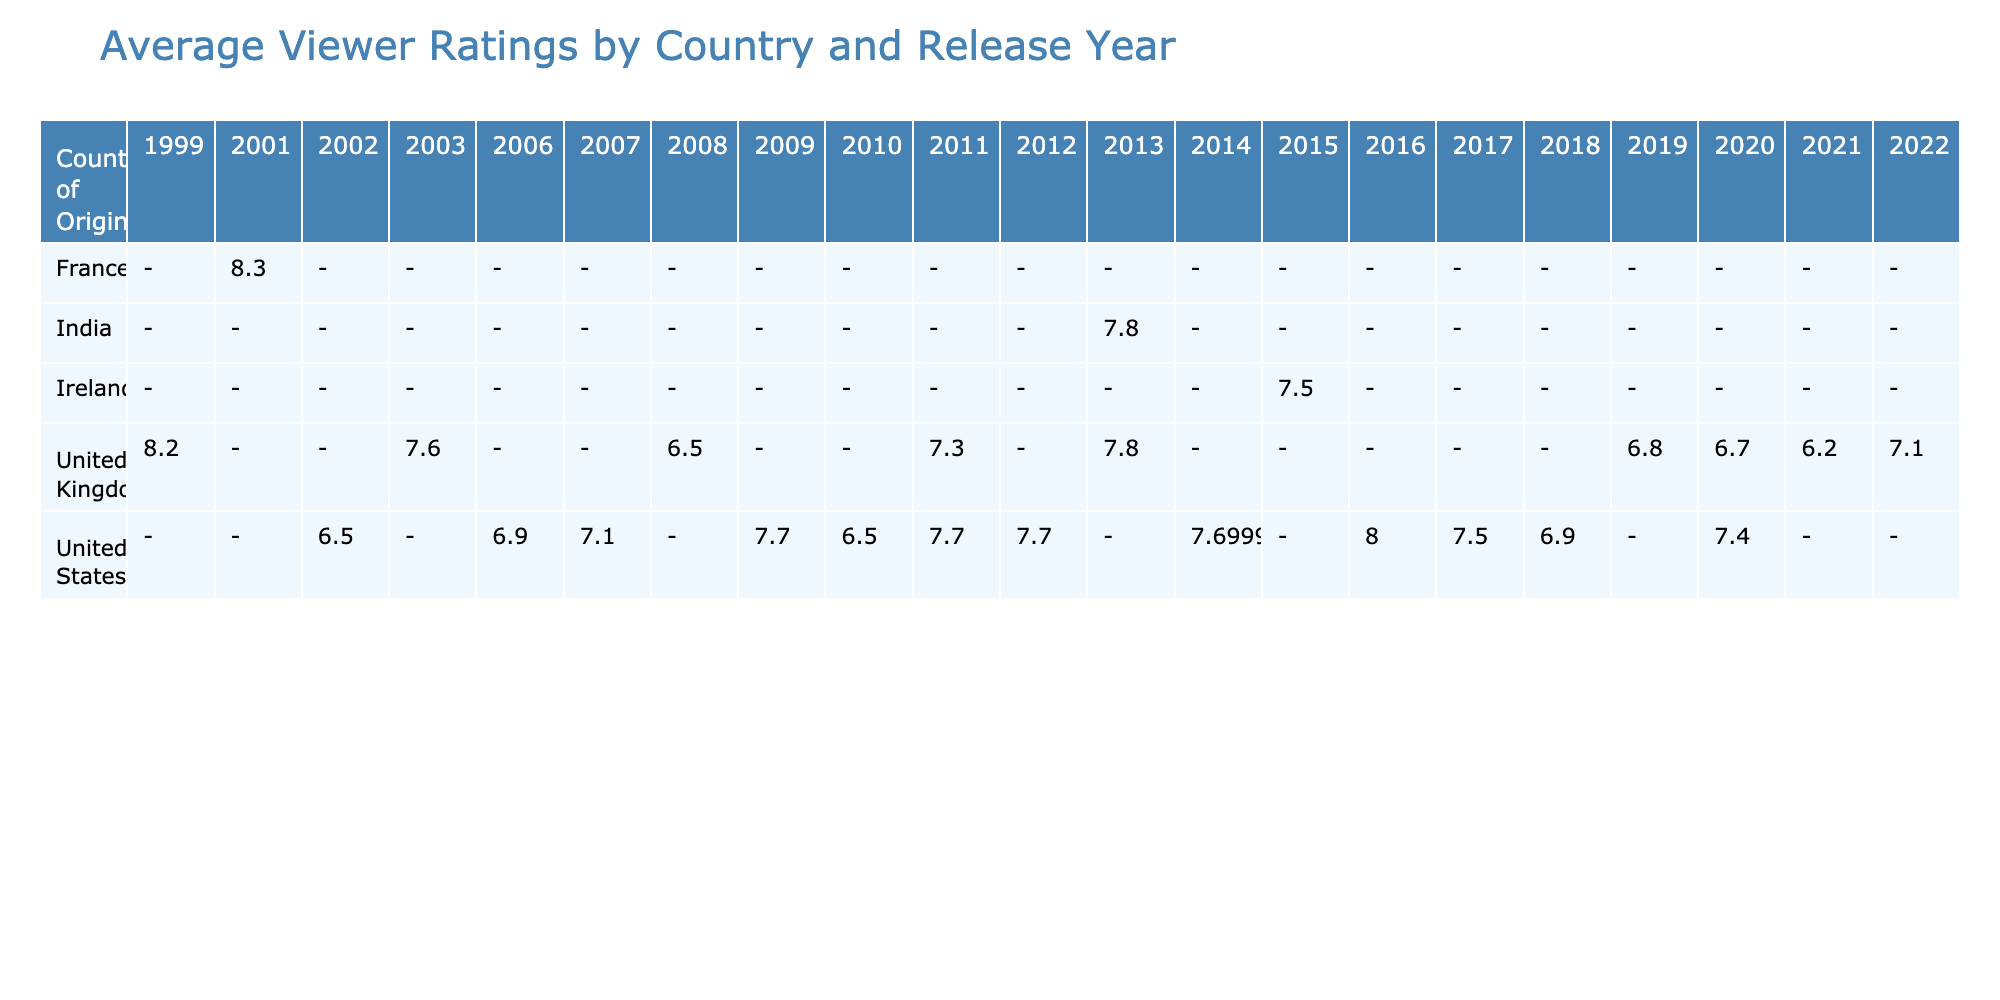What is the highest viewer rating for a romantic comedy from the United Kingdom? The highest viewer rating in the table for the United Kingdom is from "Notting Hill," which has a rating of 8.2.
Answer: 8.2 Which country had the lowest viewer rating in 2021? The table shows that the viewer rating for "Falling for Figaro" from the United Kingdom in 2021 is 6.2, which is the lowest among all ratings for that year.
Answer: 6.2 What is the average viewer rating for romantic comedies from the United States? To find the average rating, sum the viewer ratings of the romantic comedies from the United States: 6.5 + 6.9 + 7.1 + 7.7 + 6.5 + 7.7 + 7.3 + 8.1 + 7.5 + 8.0 + 6.9 + 7.4 = 86.0. There are 12 films, so the average is 86.0/12 ≈ 7.2.
Answer: 7.2 Did France produce any romantic comedies with a viewer rating above 8.0? The only French romantic comedy listed is "Amélie," which has a viewer rating of 8.3. Since this is above 8.0, the statement is true.
Answer: Yes Which country had the highest average viewer rating in 2014? In 2014, the viewer ratings for the United States were 8.1 for "The Grand Budapest Hotel" and 7.3 for "The Hundred-Foot Journey," making the average rating (8.1 + 7.3)/2 = 7.7. No other countries have data for that year, placing the United States with the highest average rating of 7.7.
Answer: United States What difference in viewer ratings is there between the highest-rated romantic comedy from the UK and the lowest-rated from the US? The highest-rated romantic comedy from the UK is "Notting Hill" with a rating of 8.2, and the lowest from the US is "My Big Fat Greek Wedding" with a rating of 6.5. The difference is 8.2 - 6.5 = 1.7.
Answer: 1.7 How many romantic comedies from India are listed, and what is its rating? There is one romantic comedy from India listed, which is "The Lunchbox," and it has a viewer rating of 7.8.
Answer: 1, rating: 7.8 Is there a romantic comedy released in 2020 with a viewer rating of less than 7.0? The table shows "Emma." from the United Kingdom with a rating of 6.7, which is below 7.0. Therefore, the statement is true.
Answer: Yes What is the viewer rating trend from 2011 to 2016 for films from the United States? Looking at the viewer ratings for the years 2011 (7.7), 2012 (7.7), 2013 (7.8), 2014 (8.1), 2015 (7.5), and 2016 (8.0), we can see an overall pattern of increasing ratings from 2011 to a peak in 2014, then a drop in 2015 followed by a slight rise again in 2016.
Answer: Increase then decrease with a slight rise 